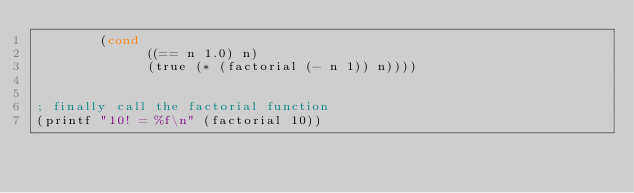Convert code to text. <code><loc_0><loc_0><loc_500><loc_500><_Lisp_>        (cond
              ((== n 1.0) n)
              (true (* (factorial (- n 1)) n))))


; finally call the factorial function
(printf "10! = %f\n" (factorial 10))
</code> 